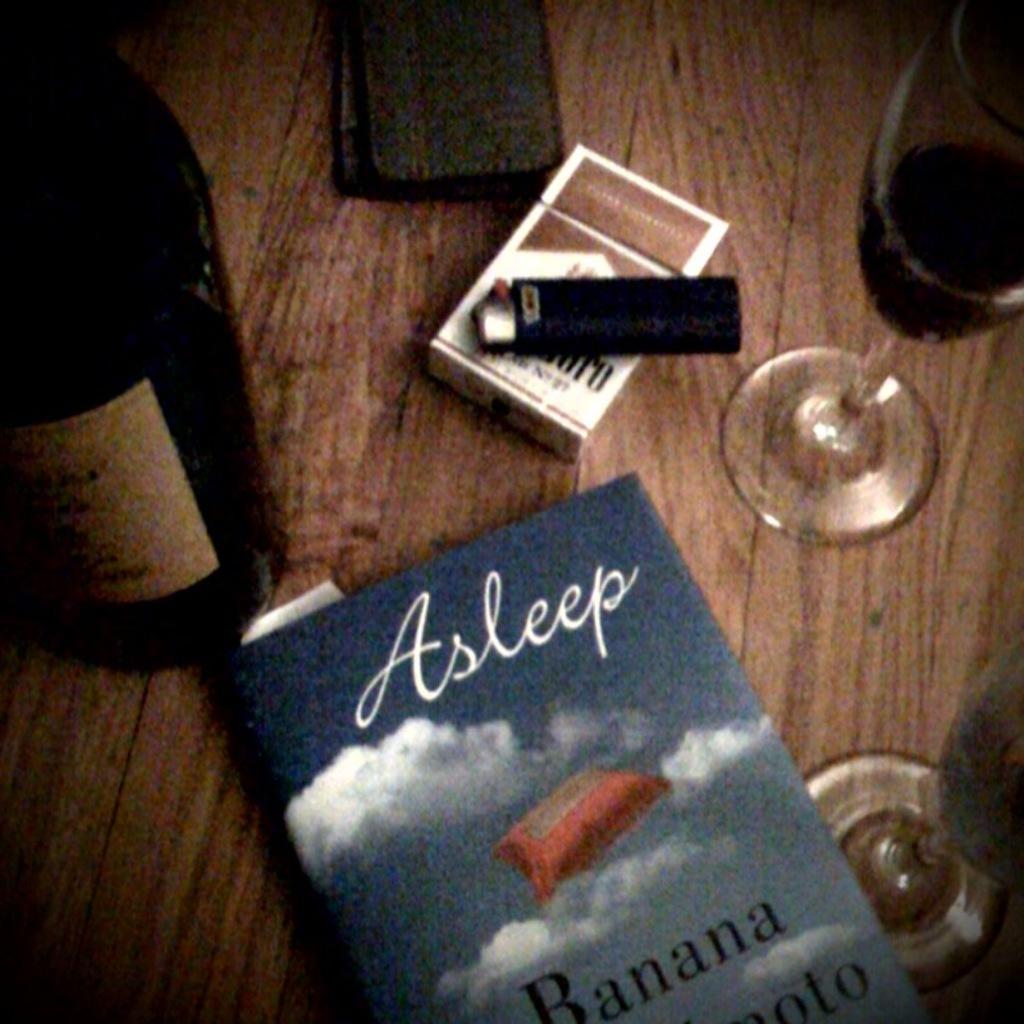What fruit word is on the cover?
Ensure brevity in your answer.  Banana. 